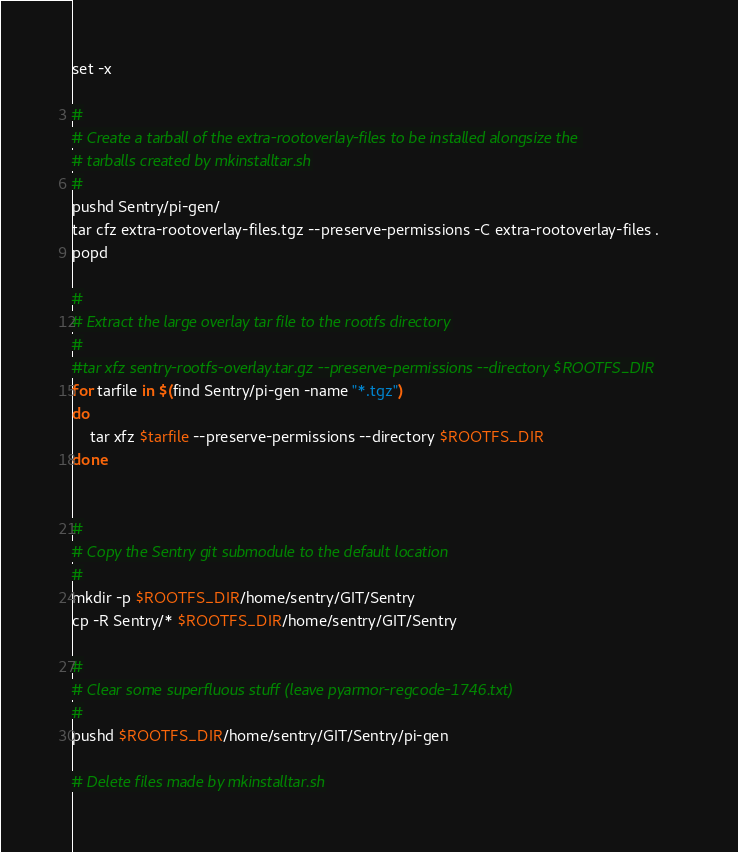Convert code to text. <code><loc_0><loc_0><loc_500><loc_500><_Bash_>set -x

#
# Create a tarball of the extra-rootoverlay-files to be installed alongsize the 
# tarballs created by mkinstalltar.sh
#
pushd Sentry/pi-gen/
tar cfz extra-rootoverlay-files.tgz --preserve-permissions -C extra-rootoverlay-files .
popd

#
# Extract the large overlay tar file to the rootfs directory
#
#tar xfz sentry-rootfs-overlay.tar.gz --preserve-permissions --directory $ROOTFS_DIR
for tarfile in $(find Sentry/pi-gen -name "*.tgz")
do
    tar xfz $tarfile --preserve-permissions --directory $ROOTFS_DIR
done


#
# Copy the Sentry git submodule to the default location
#
mkdir -p $ROOTFS_DIR/home/sentry/GIT/Sentry
cp -R Sentry/* $ROOTFS_DIR/home/sentry/GIT/Sentry

#
# Clear some superfluous stuff (leave pyarmor-regcode-1746.txt)
#
pushd $ROOTFS_DIR/home/sentry/GIT/Sentry/pi-gen

# Delete files made by mkinstalltar.sh</code> 